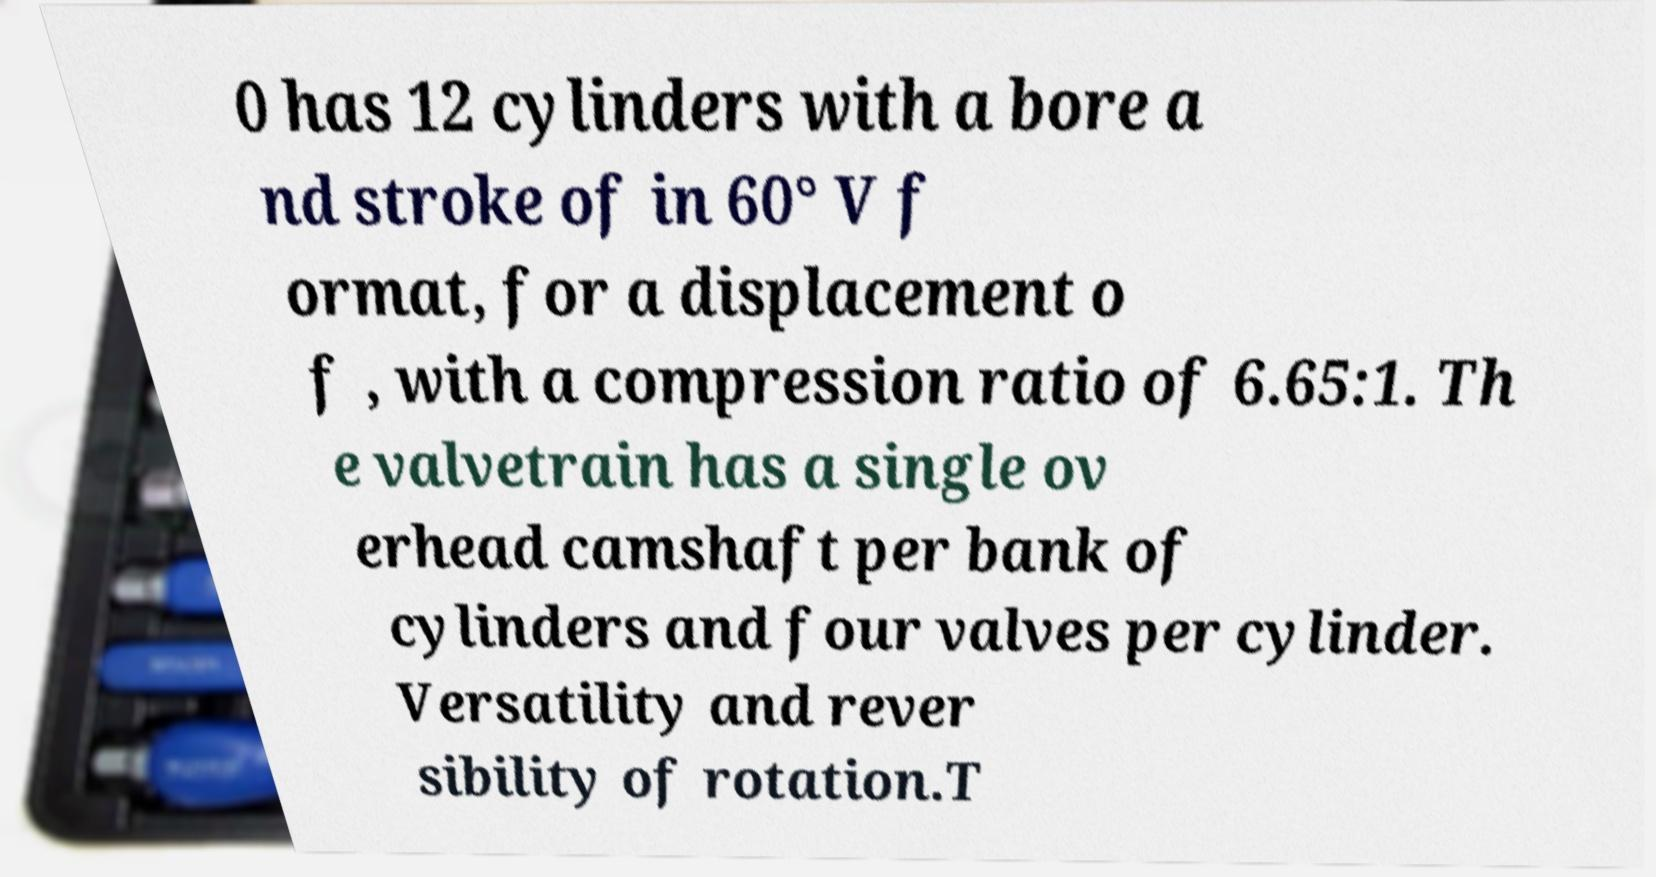There's text embedded in this image that I need extracted. Can you transcribe it verbatim? 0 has 12 cylinders with a bore a nd stroke of in 60° V f ormat, for a displacement o f , with a compression ratio of 6.65:1. Th e valvetrain has a single ov erhead camshaft per bank of cylinders and four valves per cylinder. Versatility and rever sibility of rotation.T 